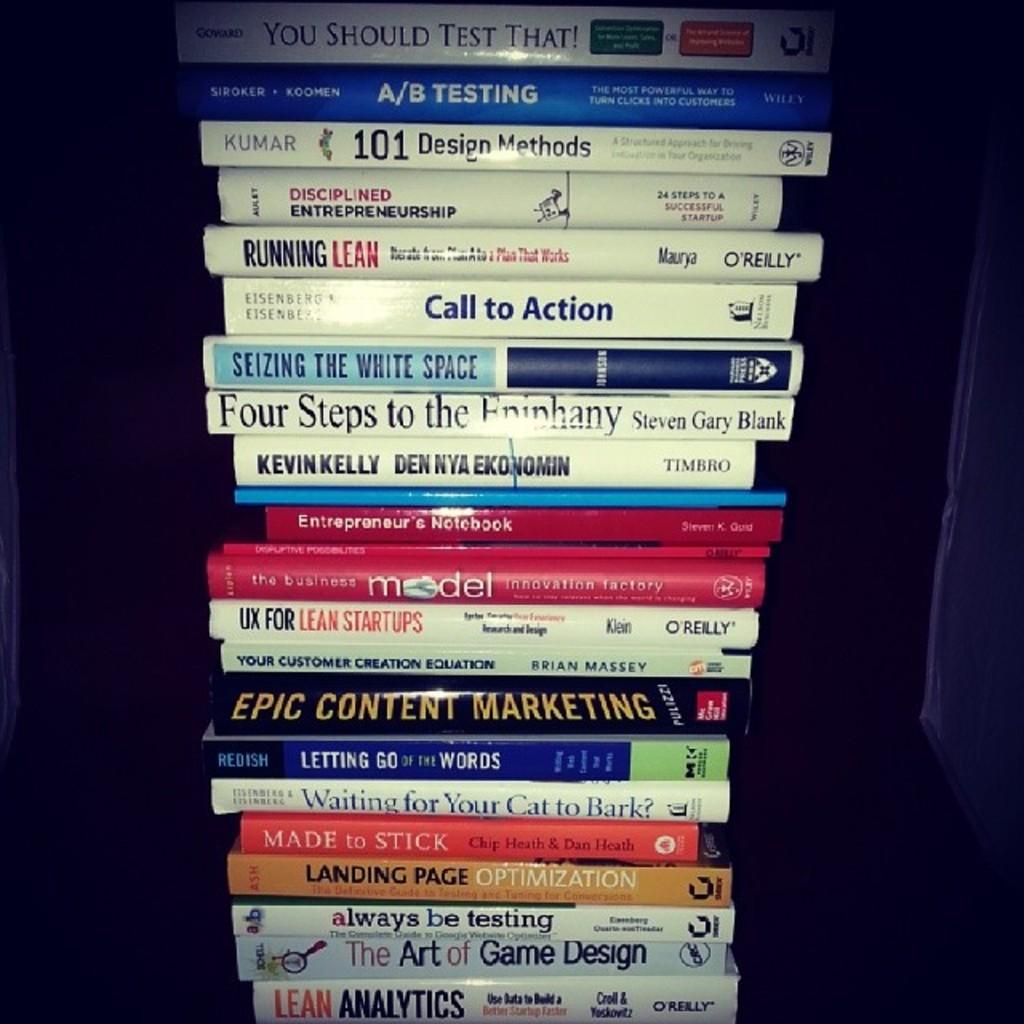What are the titles of these books?
Your response must be concise. Call to action. What is the title of the top book?
Provide a short and direct response. You should test that!. 